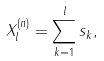<formula> <loc_0><loc_0><loc_500><loc_500>X _ { l } ^ { ( n ) } = \sum _ { k = 1 } ^ { l } s _ { k } ,</formula> 